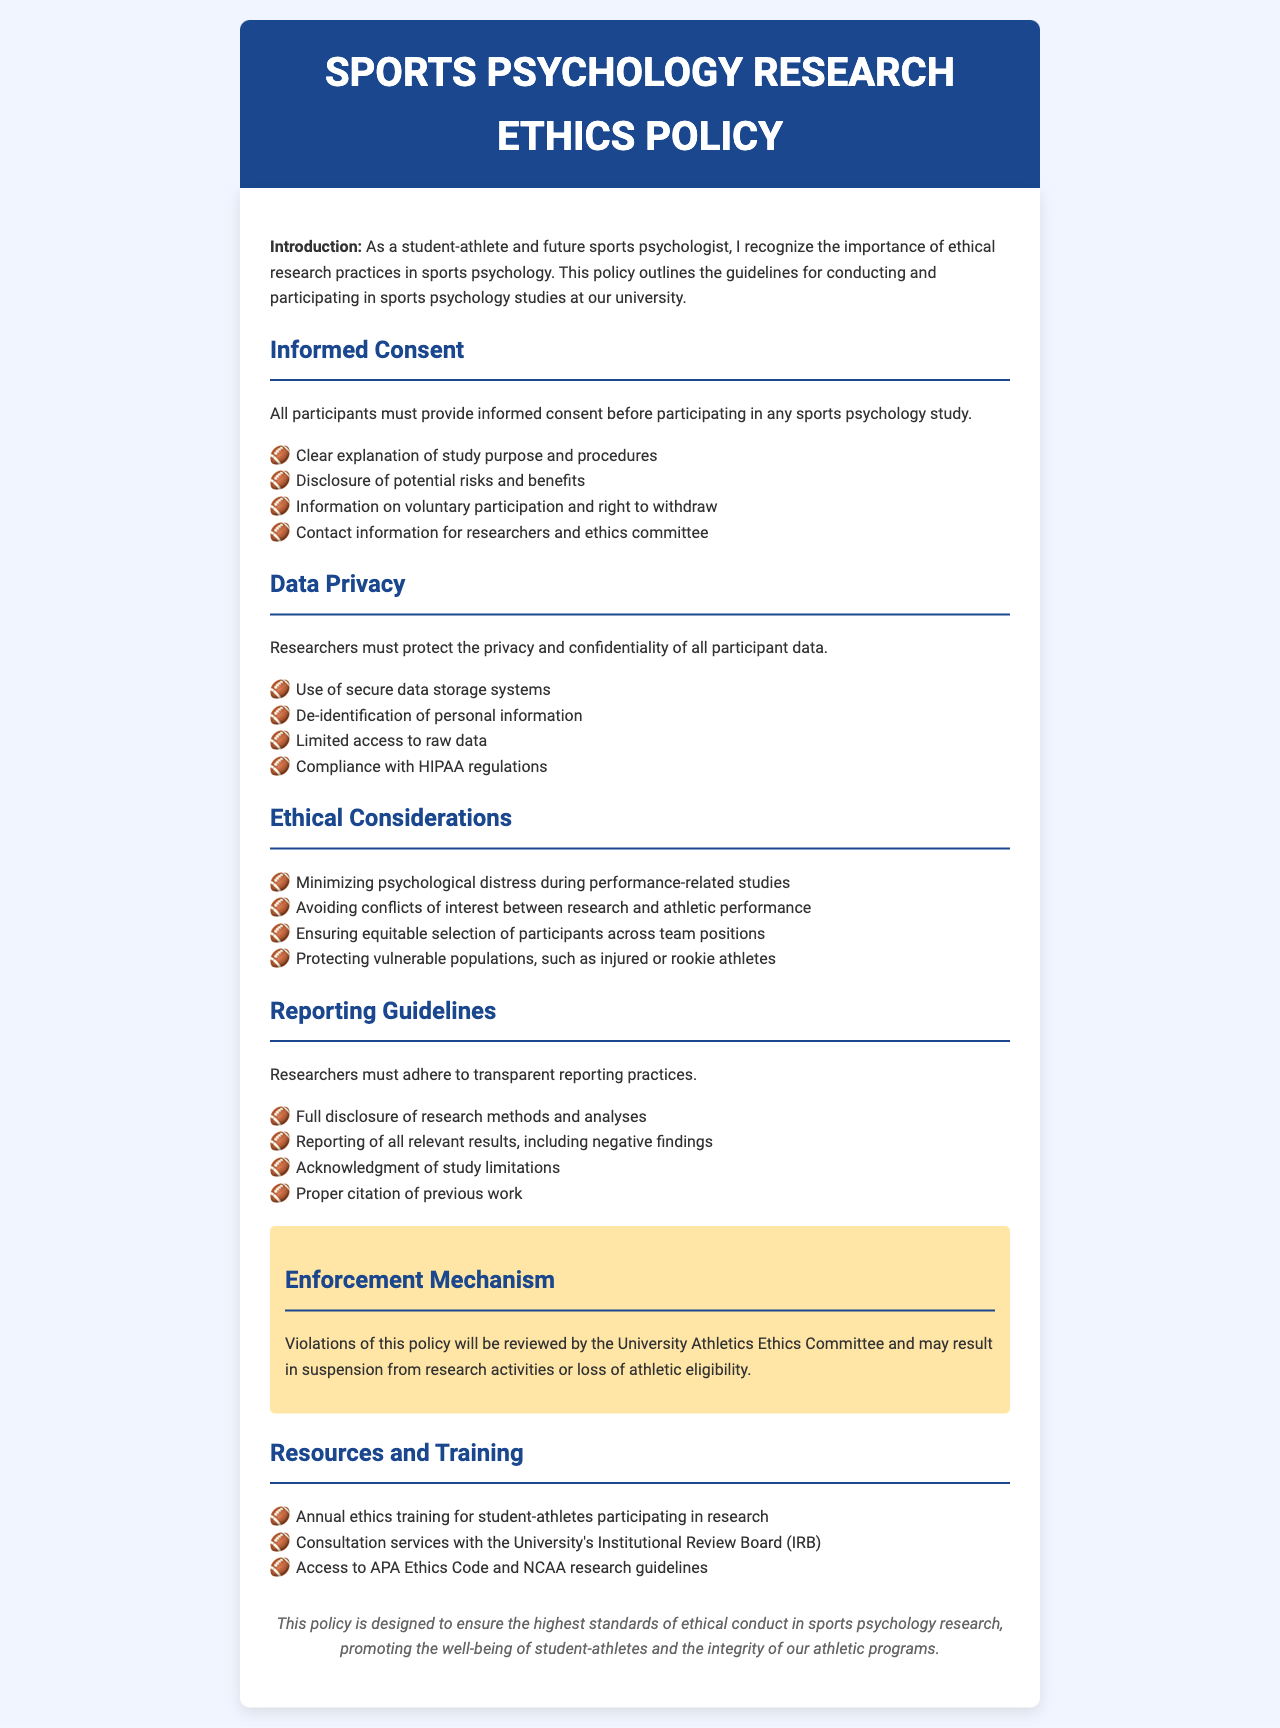What is the title of the document? The title is stated in the header of the document.
Answer: Sports Psychology Research Ethics Policy What must participants provide before participating in studies? This is outlined in the "Informed Consent" section of the document.
Answer: Informed consent What are researchers required to ensure regarding participant data? This requirement is mentioned under the "Data Privacy" section of the document.
Answer: Privacy and confidentiality Which committee reviews violations of the policy? The committee is identified in the "Enforcement Mechanism" section.
Answer: University Athletics Ethics Committee What is emphasized as an ethical consideration for participants? This is one of the points listed under "Ethical Considerations."
Answer: Minimizing psychological distress How often is ethics training required? This is specified in the "Resources and Training" section of the document.
Answer: Annual What kind of results must researchers report? This guideline is outlined in the "Reporting Guidelines" section.
Answer: All relevant results, including negative findings How are participants selected according to the ethical considerations? This principle is stated in the relevant section of the document.
Answer: Equitable selection across team positions What is the background color of the document? This is a general observation about the design of the document.
Answer: #f0f5ff 